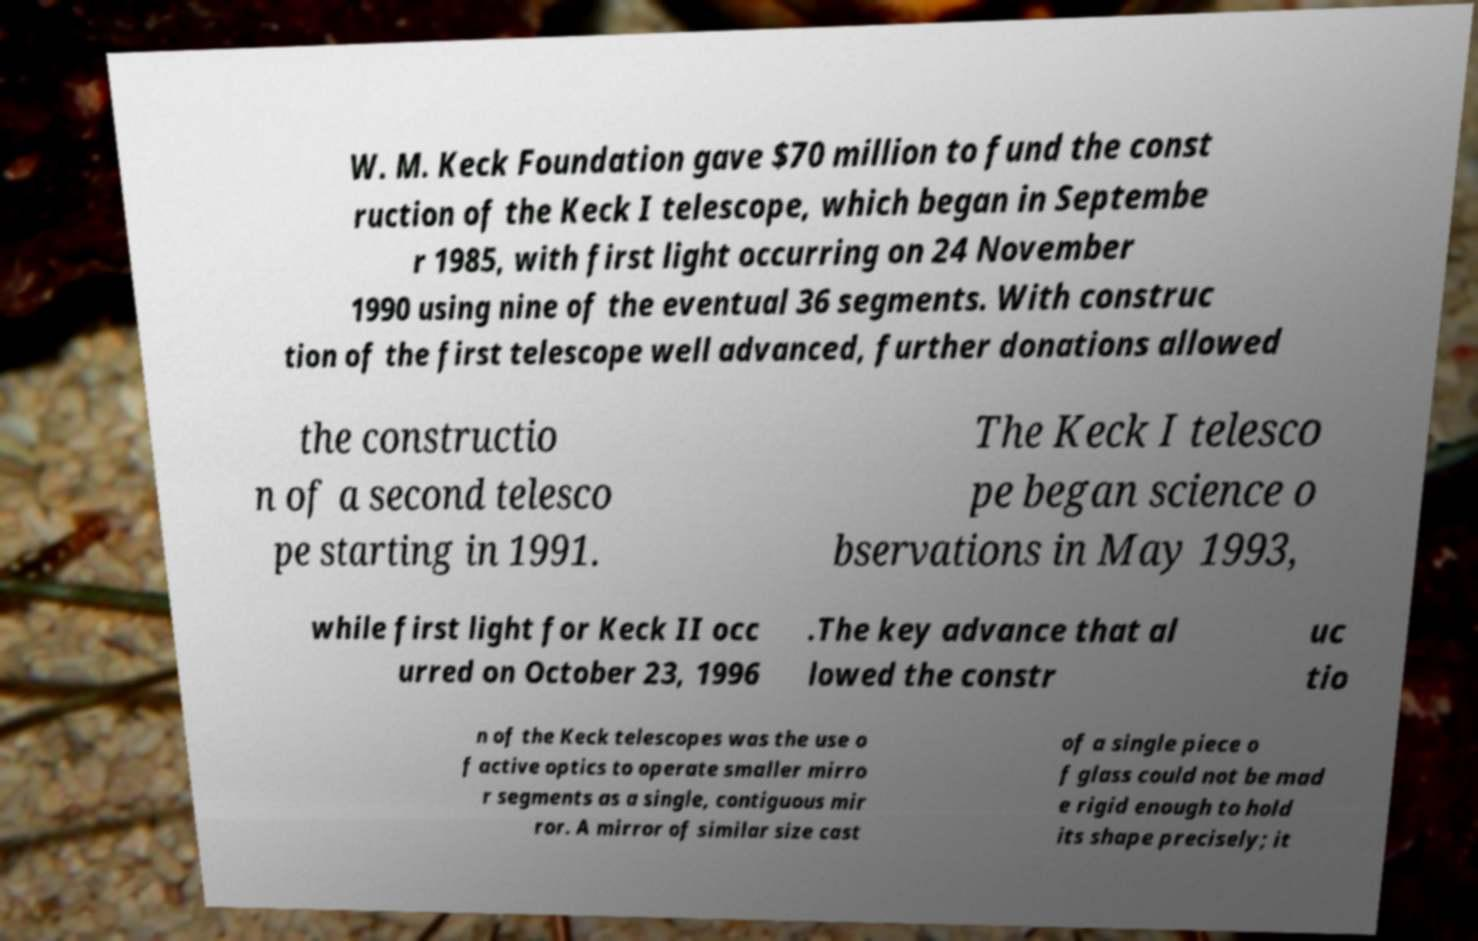Please identify and transcribe the text found in this image. W. M. Keck Foundation gave $70 million to fund the const ruction of the Keck I telescope, which began in Septembe r 1985, with first light occurring on 24 November 1990 using nine of the eventual 36 segments. With construc tion of the first telescope well advanced, further donations allowed the constructio n of a second telesco pe starting in 1991. The Keck I telesco pe began science o bservations in May 1993, while first light for Keck II occ urred on October 23, 1996 .The key advance that al lowed the constr uc tio n of the Keck telescopes was the use o f active optics to operate smaller mirro r segments as a single, contiguous mir ror. A mirror of similar size cast of a single piece o f glass could not be mad e rigid enough to hold its shape precisely; it 